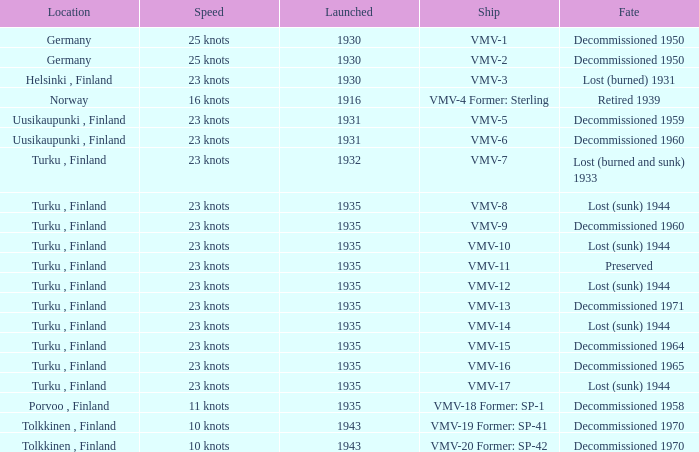What is the average launch date of the vmv-1 vessel in Germany? 1930.0. 